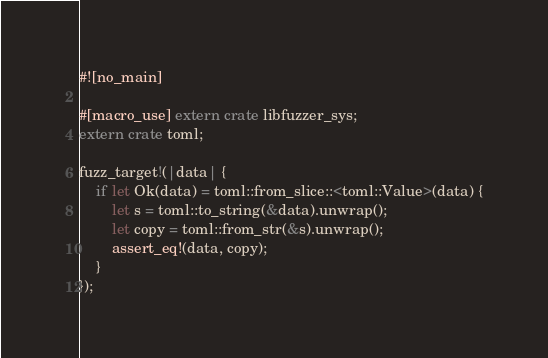Convert code to text. <code><loc_0><loc_0><loc_500><loc_500><_Rust_>#![no_main]

#[macro_use] extern crate libfuzzer_sys;
extern crate toml;

fuzz_target!(|data| {
    if let Ok(data) = toml::from_slice::<toml::Value>(data) {
        let s = toml::to_string(&data).unwrap();
        let copy = toml::from_str(&s).unwrap();
        assert_eq!(data, copy);
    }
});
</code> 